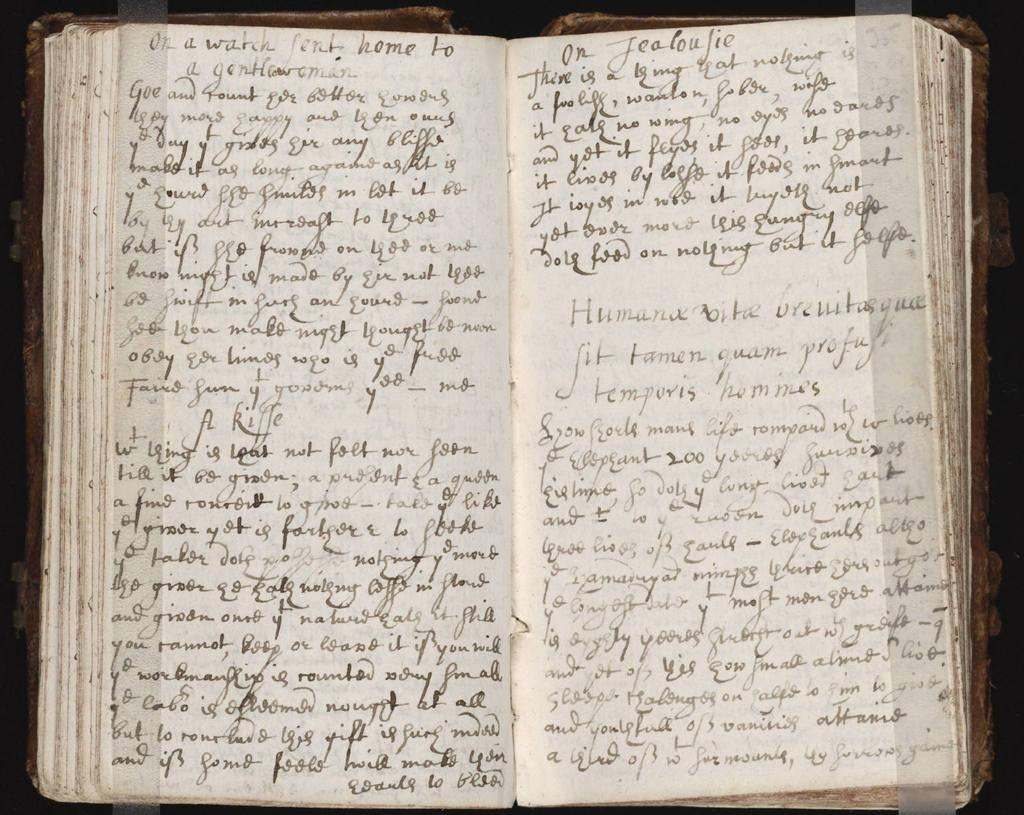<image>
Write a terse but informative summary of the picture. A book open that has the first words of the last page as "On a watch 